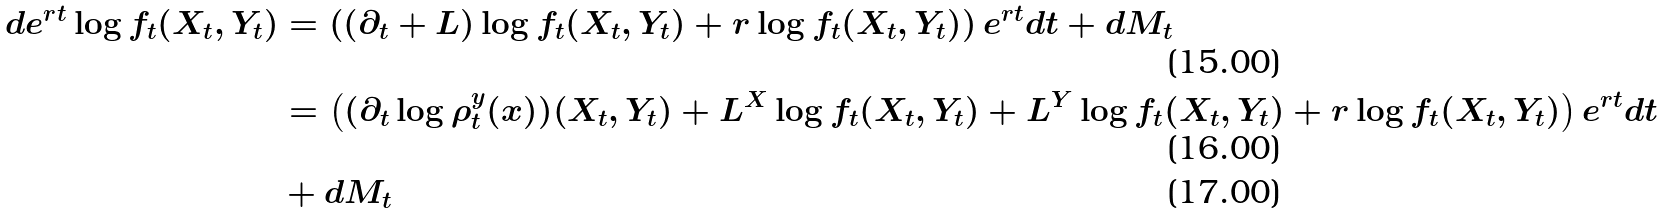<formula> <loc_0><loc_0><loc_500><loc_500>d e ^ { r t } \log f _ { t } ( X _ { t } , Y _ { t } ) & = \left ( ( \partial _ { t } + L ) \log f _ { t } ( X _ { t } , Y _ { t } ) + r \log f _ { t } ( X _ { t } , Y _ { t } ) \right ) e ^ { r t } d t + d M _ { t } \\ & = \left ( ( \partial _ { t } \log \rho ^ { y } _ { t } ( x ) ) ( X _ { t } , Y _ { t } ) + L ^ { X } \log f _ { t } ( X _ { t } , Y _ { t } ) + L ^ { Y } \log f _ { t } ( X _ { t } , Y _ { t } ) + r \log f _ { t } ( X _ { t } , Y _ { t } ) \right ) e ^ { r t } d t \\ & + d M _ { t }</formula> 